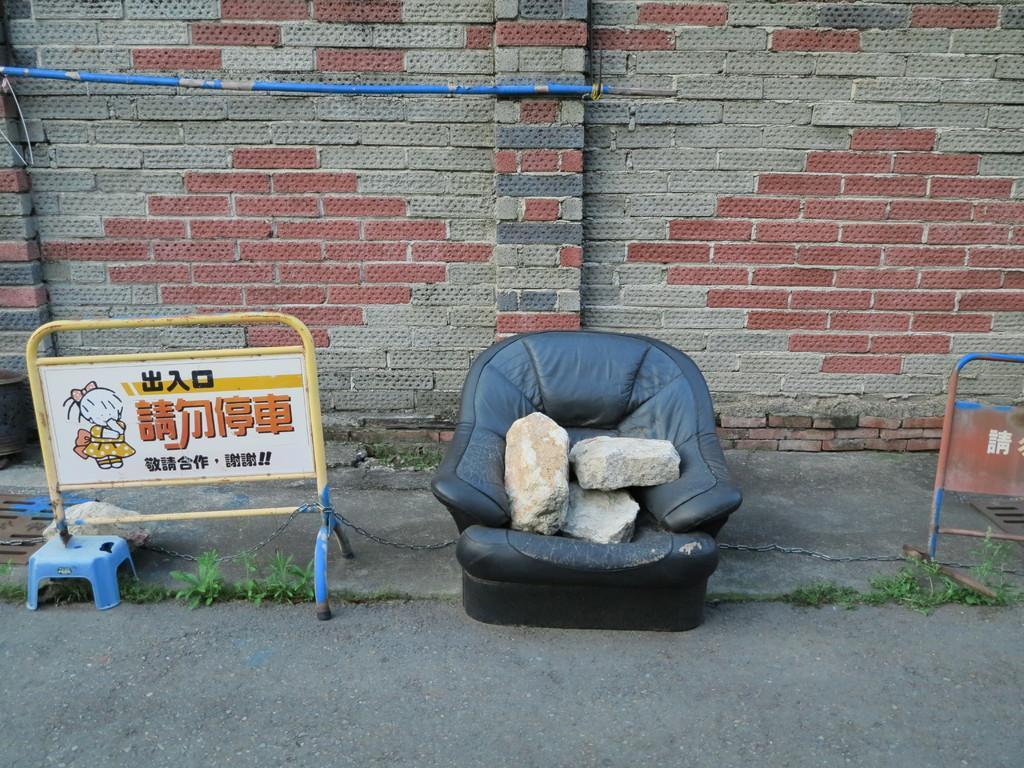Could you give a brief overview of what you see in this image? There are barricades and few small plants on both the sides of the image, there are stones on the sofa in the center. There is a pipe and a wall in the background. 